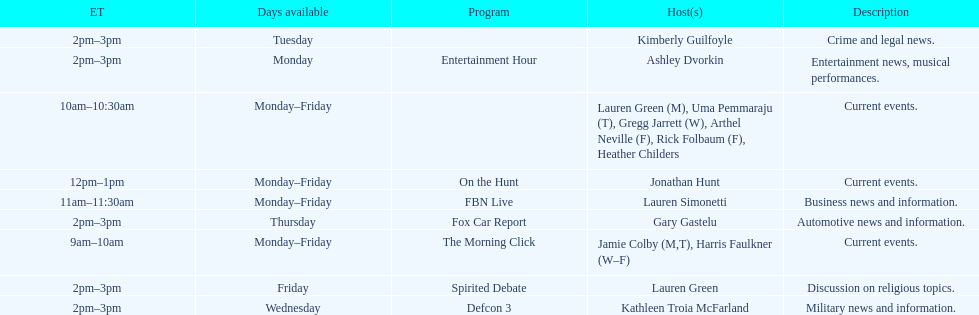On how many weekdays does fbn live air their show? 5. 